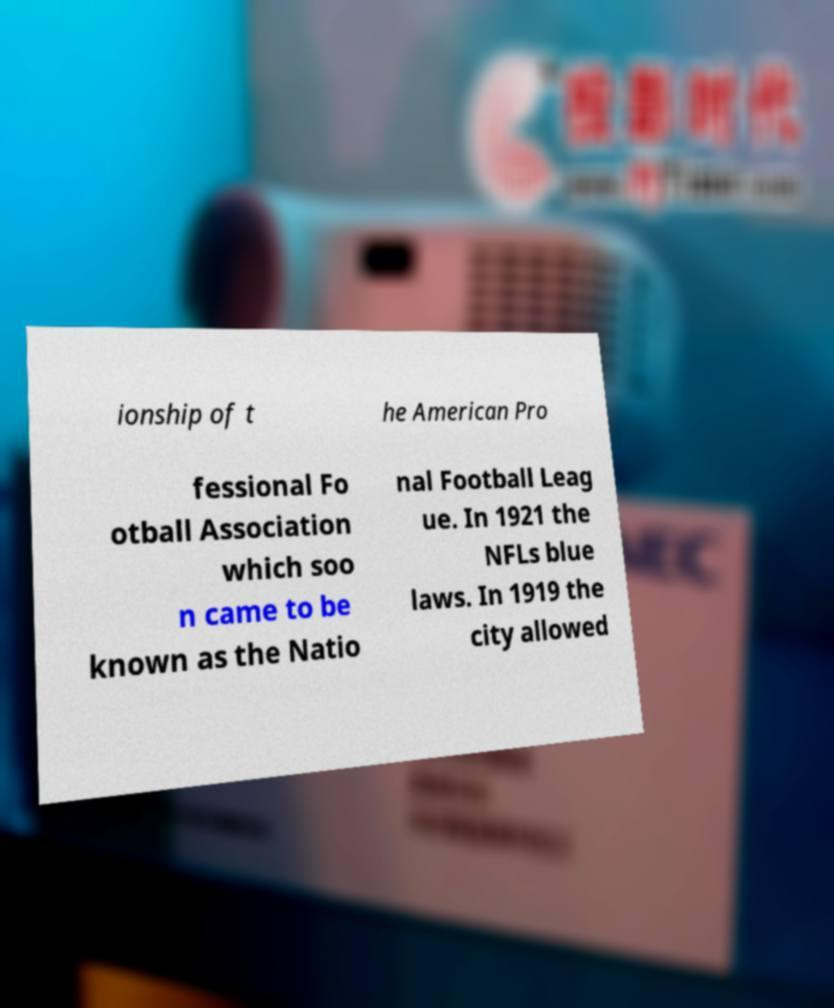Can you read and provide the text displayed in the image?This photo seems to have some interesting text. Can you extract and type it out for me? ionship of t he American Pro fessional Fo otball Association which soo n came to be known as the Natio nal Football Leag ue. In 1921 the NFLs blue laws. In 1919 the city allowed 